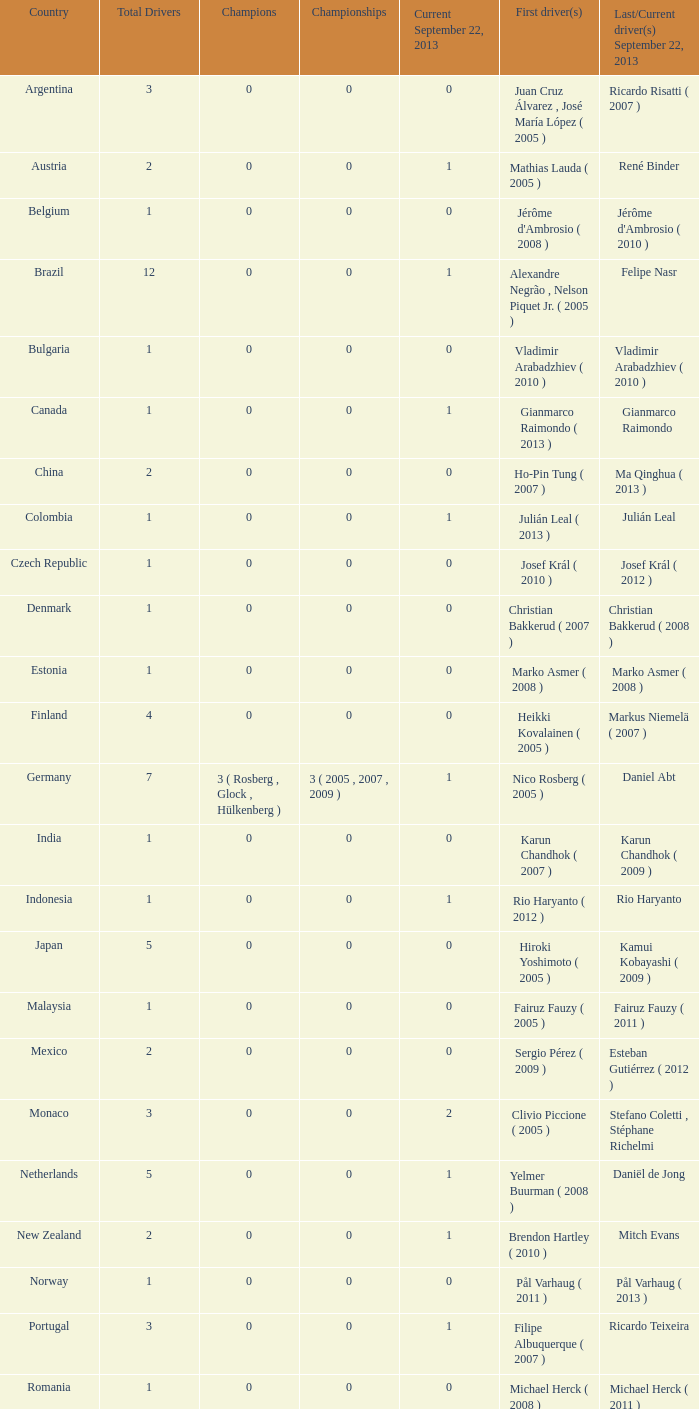What was the total number of champions when gianmarco raimondo was the last one to win? 0.0. 